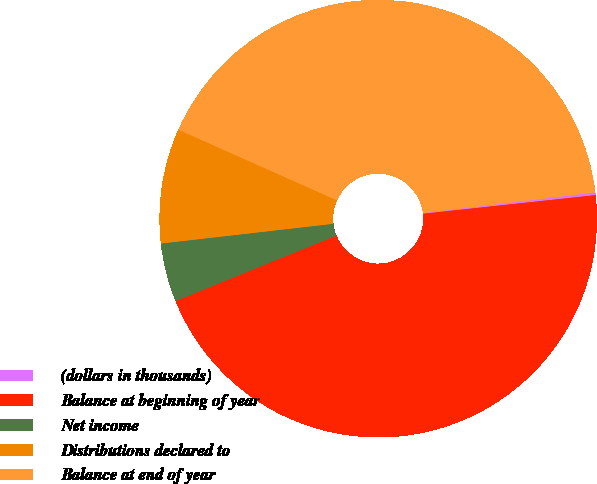Convert chart. <chart><loc_0><loc_0><loc_500><loc_500><pie_chart><fcel>(dollars in thousands)<fcel>Balance at beginning of year<fcel>Net income<fcel>Distributions declared to<fcel>Balance at end of year<nl><fcel>0.2%<fcel>45.56%<fcel>4.34%<fcel>8.48%<fcel>41.42%<nl></chart> 